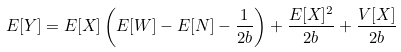Convert formula to latex. <formula><loc_0><loc_0><loc_500><loc_500>E [ Y ] = E [ X ] \left ( E [ W ] - E [ N ] - \frac { 1 } { 2 b } \right ) + \frac { E [ X ] ^ { 2 } } { 2 b } + \frac { V [ X ] } { 2 b }</formula> 